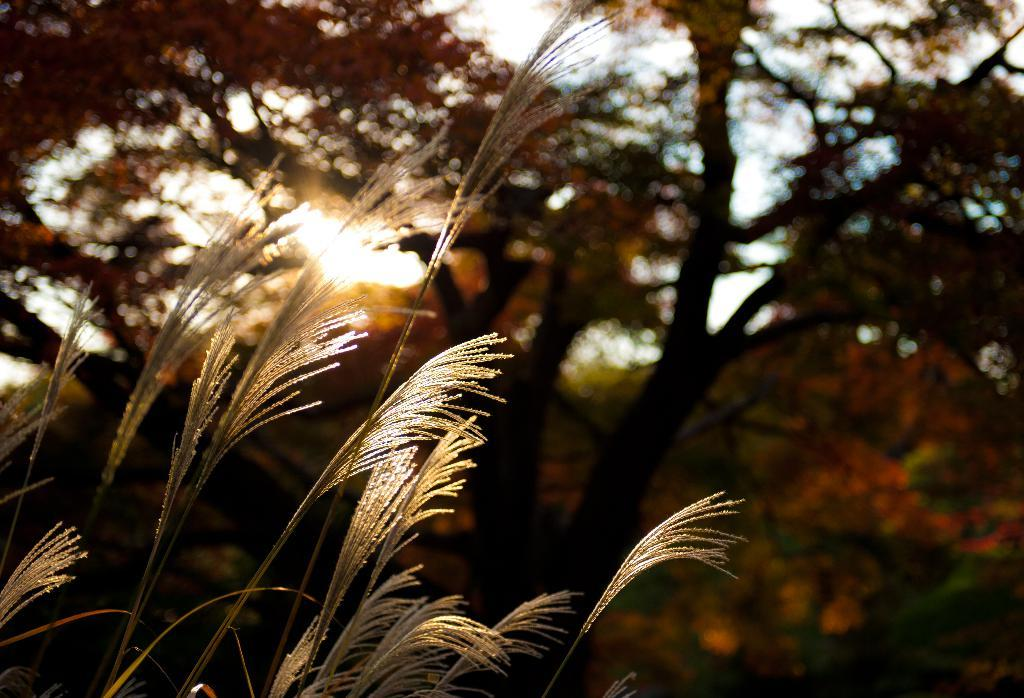What type of vegetation can be seen in the image? There is grass visible in the image. What can be seen in the background of the image? There are many trees in the background of the image. What is visible at the top of the image? The sky is visible at the top of the image. Can you see any bombs in the image? There are no bombs present in the image. What type of thing is hanging from the trees in the image? There is no thing hanging from the trees in the image; only trees are visible in the background. 